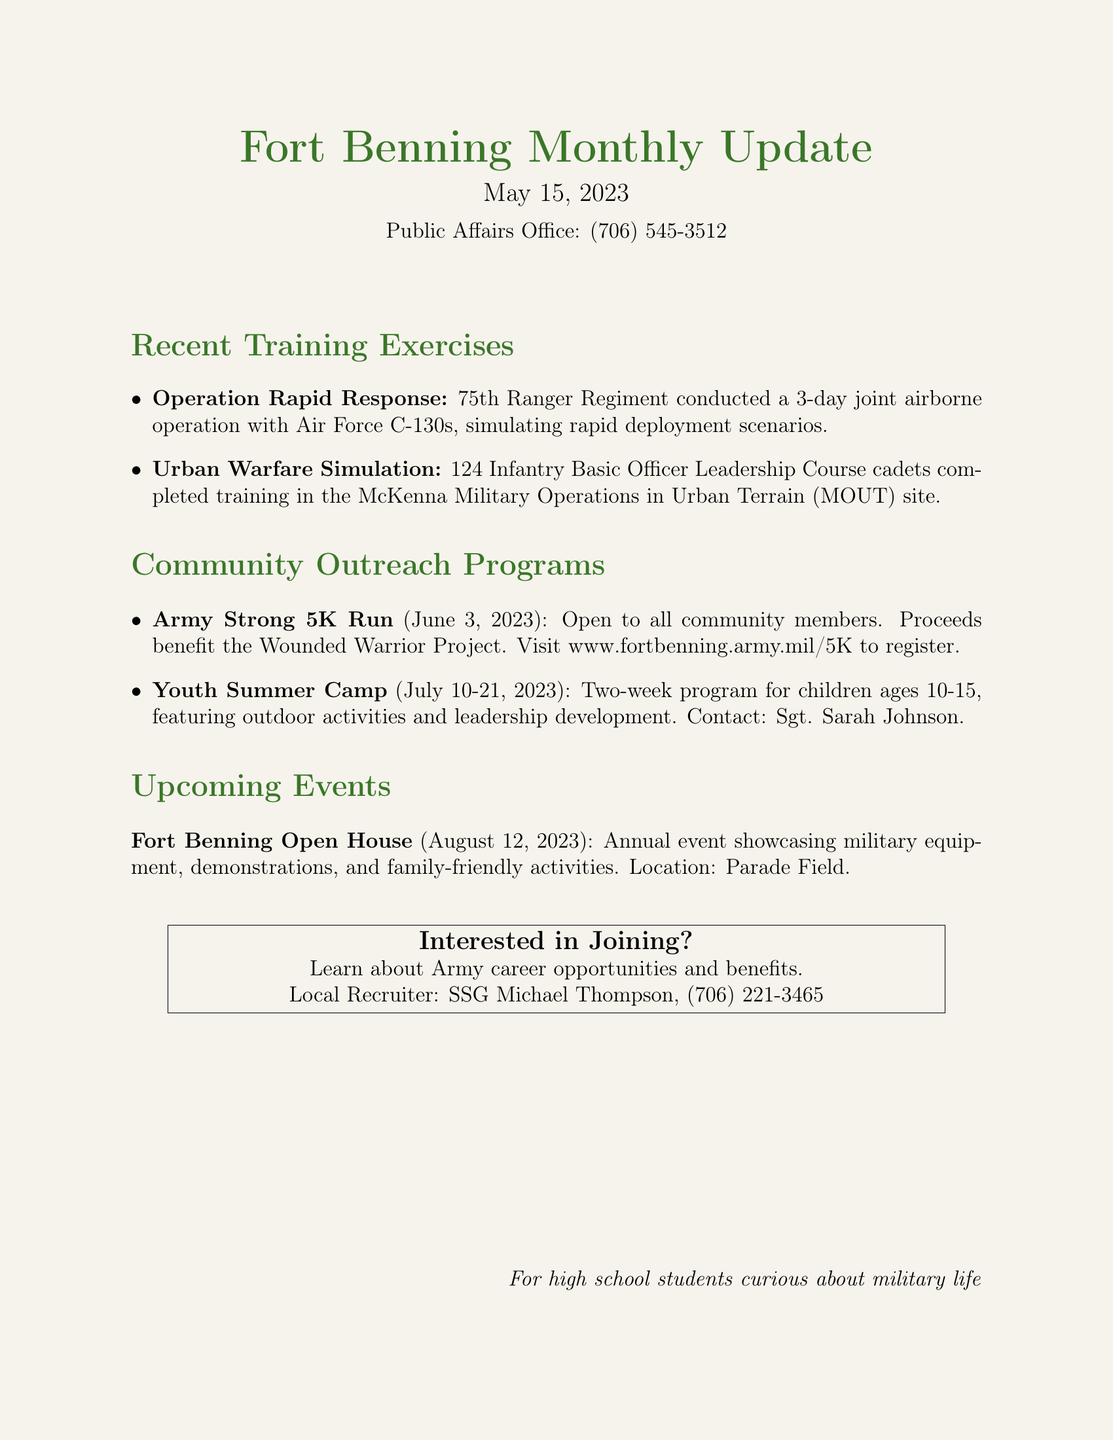what is the name of the operation conducted by the 75th Ranger Regiment? The document mentions "Operation Rapid Response" as the operation conducted by the 75th Ranger Regiment.
Answer: Operation Rapid Response how long did the Urban Warfare Simulation training last? The Urban Warfare Simulation lasted for a specific training exercise without a defined duration mentioned, but it's implied that it is part of the Basic Officer Leadership Course.
Answer: Duration not specified what is the date of the Army Strong 5K Run? The document states that the Army Strong 5K Run is scheduled for June 3, 2023.
Answer: June 3, 2023 who is responsible for the Youth Summer Camp? The document lists "Sgt. Sarah Johnson" as the contact for the Youth Summer Camp.
Answer: Sgt. Sarah Johnson what is the main purpose of the proceeds from the Army Strong 5K Run? The document notes that the proceeds from the event benefit the Wounded Warrior Project.
Answer: Wounded Warrior Project when is the Fort Benning Open House taking place? The document indicates that the Fort Benning Open House will be held on August 12, 2023.
Answer: August 12, 2023 how many cadets completed the Urban Warfare Simulation training? The document states that 124 Infantry Basic Officer Leadership Course cadets completed the training.
Answer: 124 cadets what type of activities will the Youth Summer Camp feature? The document describes outdoor activities and leadership development as features of the Youth Summer Camp.
Answer: Outdoor activities and leadership development who can participate in the Army Strong 5K Run? The document mentions that the Army Strong 5K Run is open to all community members.
Answer: All community members 